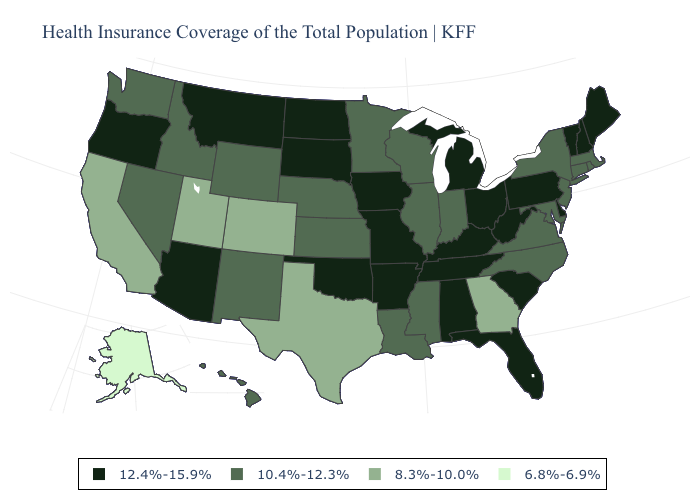What is the value of West Virginia?
Quick response, please. 12.4%-15.9%. Name the states that have a value in the range 10.4%-12.3%?
Answer briefly. Connecticut, Hawaii, Idaho, Illinois, Indiana, Kansas, Louisiana, Maryland, Massachusetts, Minnesota, Mississippi, Nebraska, Nevada, New Jersey, New Mexico, New York, North Carolina, Rhode Island, Virginia, Washington, Wisconsin, Wyoming. Does Pennsylvania have a higher value than Missouri?
Concise answer only. No. Name the states that have a value in the range 10.4%-12.3%?
Short answer required. Connecticut, Hawaii, Idaho, Illinois, Indiana, Kansas, Louisiana, Maryland, Massachusetts, Minnesota, Mississippi, Nebraska, Nevada, New Jersey, New Mexico, New York, North Carolina, Rhode Island, Virginia, Washington, Wisconsin, Wyoming. What is the value of Nebraska?
Answer briefly. 10.4%-12.3%. Is the legend a continuous bar?
Answer briefly. No. What is the lowest value in the Northeast?
Be succinct. 10.4%-12.3%. Does the map have missing data?
Short answer required. No. Among the states that border Kansas , does Oklahoma have the highest value?
Be succinct. Yes. Does Ohio have the lowest value in the MidWest?
Concise answer only. No. What is the value of Alabama?
Short answer required. 12.4%-15.9%. What is the value of Mississippi?
Quick response, please. 10.4%-12.3%. What is the value of Colorado?
Keep it brief. 8.3%-10.0%. Does the map have missing data?
Write a very short answer. No. What is the highest value in the Northeast ?
Keep it brief. 12.4%-15.9%. 